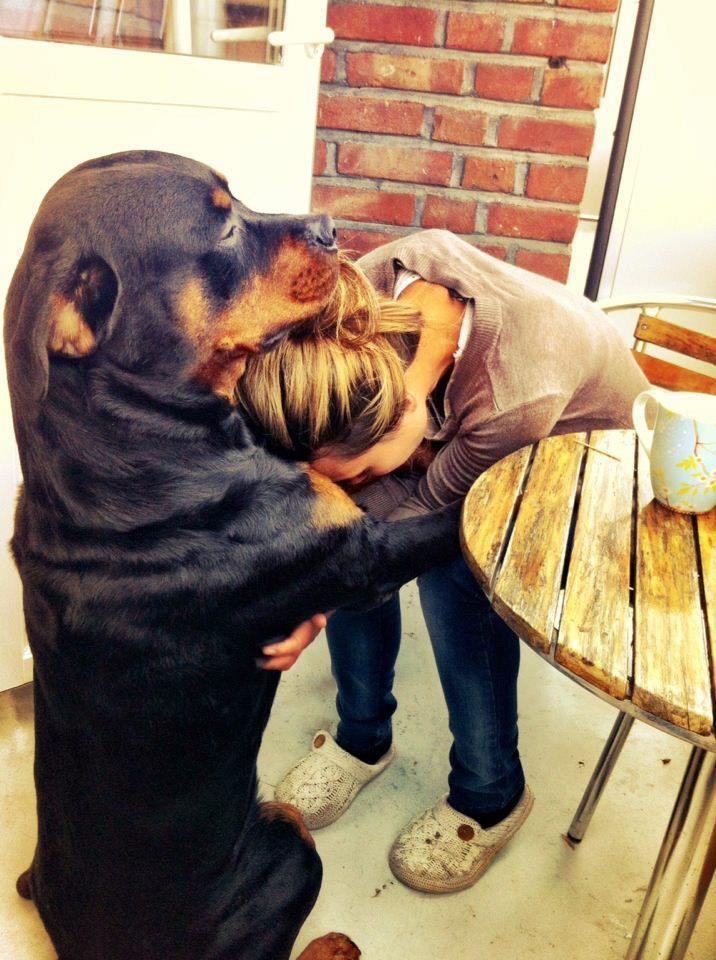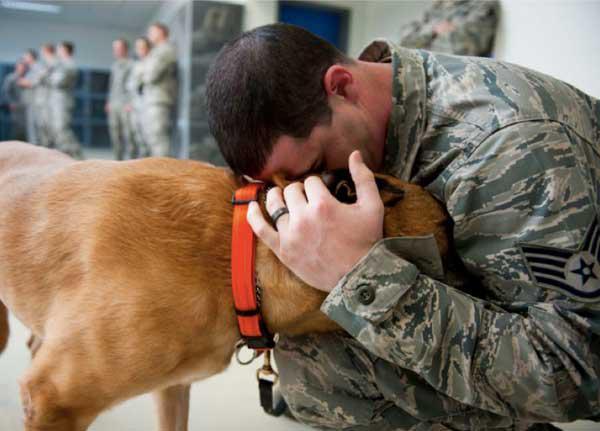The first image is the image on the left, the second image is the image on the right. Examine the images to the left and right. Is the description "There is a person wearing camouflage hugging a dog." accurate? Answer yes or no. Yes. The first image is the image on the left, the second image is the image on the right. For the images shown, is this caption "One image shows a person in a pony-tail with head bent toward a dog, and the other image shows a male in an olive jacket with head next to a dog." true? Answer yes or no. Yes. 